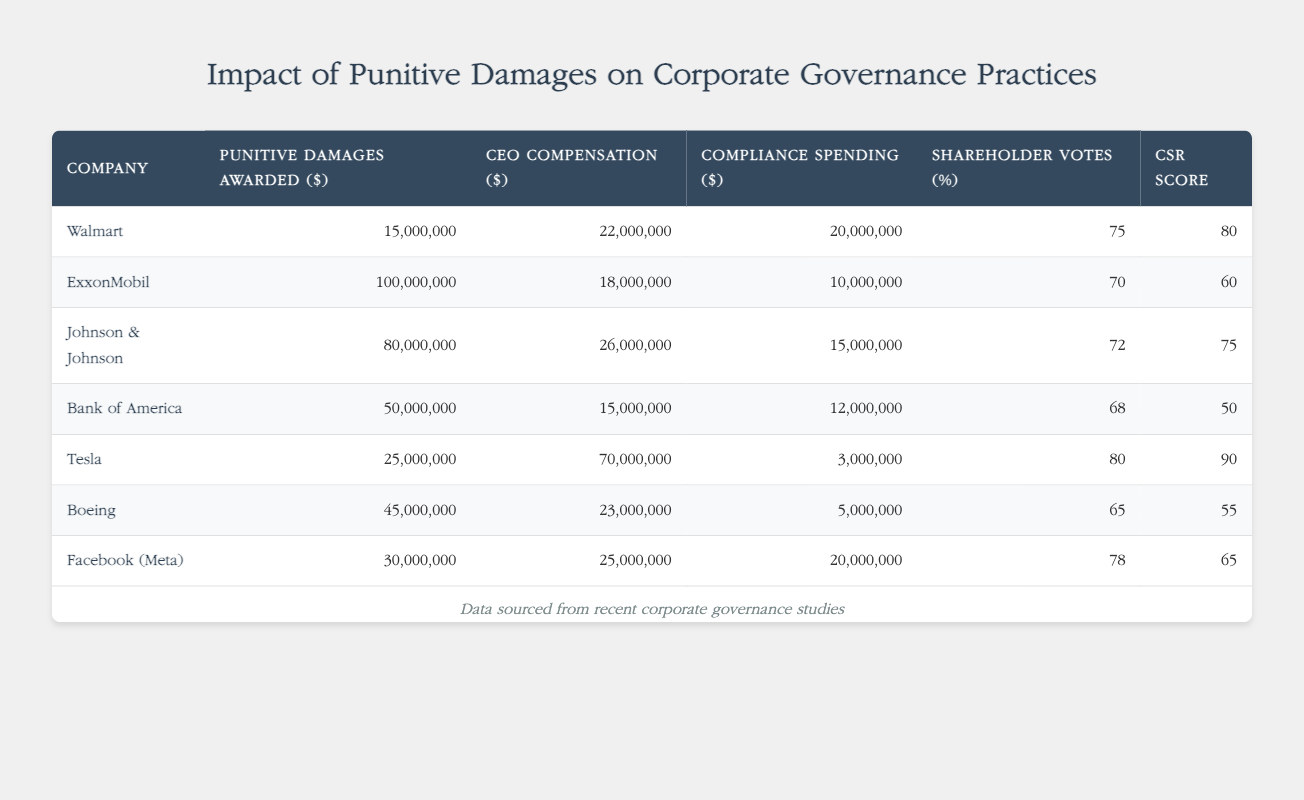What is the punitive damages awarded to Johnson & Johnson? The table shows that Johnson & Johnson has been awarded punitive damages of 80,000,000 dollars.
Answer: 80,000,000 Which company has the highest CEO compensation, and how much is it? The table indicates that Tesla has the highest CEO compensation at 70,000,000 dollars.
Answer: Tesla, 70,000,000 What is the average compliance spending across all companies listed? To find the average compliance spending, we add all the compliance spending values: 20,000,000 + 10,000,000 + 15,000,000 + 12,000,000 + 3,000,000 + 5,000,000 + 20,000,000 = 95,000,000. There are 7 companies, so the average is 95,000,000 / 7 ≈ 13,571,429.
Answer: 13,571,429 Does a higher amount of punitive damages correspond to a higher Corporate Social Responsibility (CSR) Score? Examining the table reveals that, while some companies with higher punitive damages like Johnson & Johnson and ExxonMobil have lower CSR scores (75 and 60, respectively), others like Tesla (25,000,000 in punitive damages) have the highest CSR score at 90. Thus, the relationship is not consistent.
Answer: No What is the total amount of punitive damages awarded to the listed companies? By summing the punitive damages awarded: 15,000,000 + 100,000,000 + 80,000,000 + 50,000,000 + 25,000,000 + 45,000,000 + 30,000,000 = 345,000,000 dollars in total punitive damages awarded to all listed companies.
Answer: 345,000,000 Which company has the lowest Corporate Social Responsibility (CSR) Score and what is it? The CSR score for Bank of America is the lowest listed in the table, which is 50.
Answer: Bank of America, 50 How does the compliance spending of Facebook (Meta) compare to the average compliance spending? Facebook (Meta) has compliance spending of 20,000,000. The average compliance spending calculated earlier is approximately 13,571,429. Thus, Facebook's spending is higher than average.
Answer: Higher than average Does Walmart have a lower compliance spending than Johnson & Johnson? Walmart's compliance spending is 20,000,000 while Johnson & Johnson's is 15,000,000. Since 20,000,000 is greater than 15,000,000, Walmart does not have lower spending than Johnson & Johnson.
Answer: No 